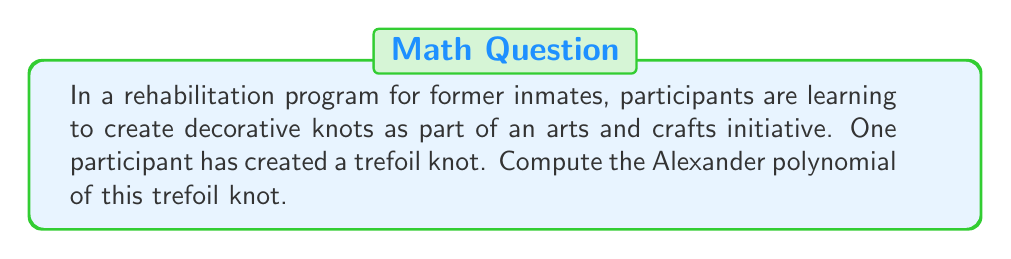Show me your answer to this math problem. To compute the Alexander polynomial of a trefoil knot, we'll follow these steps:

1) First, we need to create a diagram of the trefoil knot and label its arcs and crossings. Let's label the arcs as a, b, and c, and the crossings as 1, 2, and 3.

2) Next, we create the Alexander matrix. For a trefoil knot, this is a 3x3 matrix. Each row corresponds to a crossing, and each column corresponds to an arc. The entries are determined by the following rules:
   - For the overcrossing arc: 1 - t
   - For the undercrossing arc to the right: -1
   - For the undercrossing arc to the left: t
   - 0 for arcs not involved in the crossing

3) Our Alexander matrix for the trefoil knot looks like this:

   $$
   \begin{pmatrix}
   1-t & -1 & t \\
   t & 1-t & -1 \\
   -1 & t & 1-t
   \end{pmatrix}
   $$

4) To find the Alexander polynomial, we need to calculate the determinant of any 2x2 minor of this matrix and divide by $(1-t)$.

5) Let's choose the minor formed by deleting the first row and first column:

   $$
   \det \begin{pmatrix}
   1-t & -1 \\
   t & 1-t
   \end{pmatrix} = (1-t)^2 - (-t) = 1 - 2t + t^2 + t = 1 - t + t^2
   $$

6) Now, we divide this by $(1-t)$:

   $$\frac{1 - t + t^2}{1-t} = 1 - t + t^2$$

7) Therefore, the Alexander polynomial of the trefoil knot is $1 - t + t^2$.
Answer: $1 - t + t^2$ 